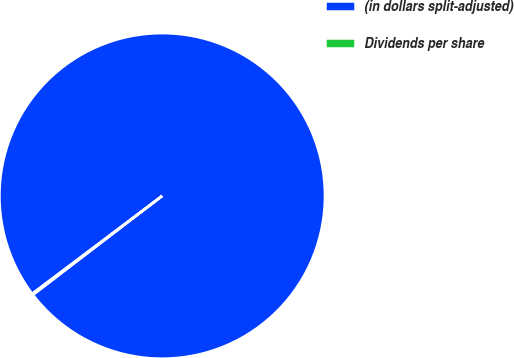Convert chart to OTSL. <chart><loc_0><loc_0><loc_500><loc_500><pie_chart><fcel>(in dollars split-adjusted)<fcel>Dividends per share<nl><fcel>99.87%<fcel>0.13%<nl></chart> 